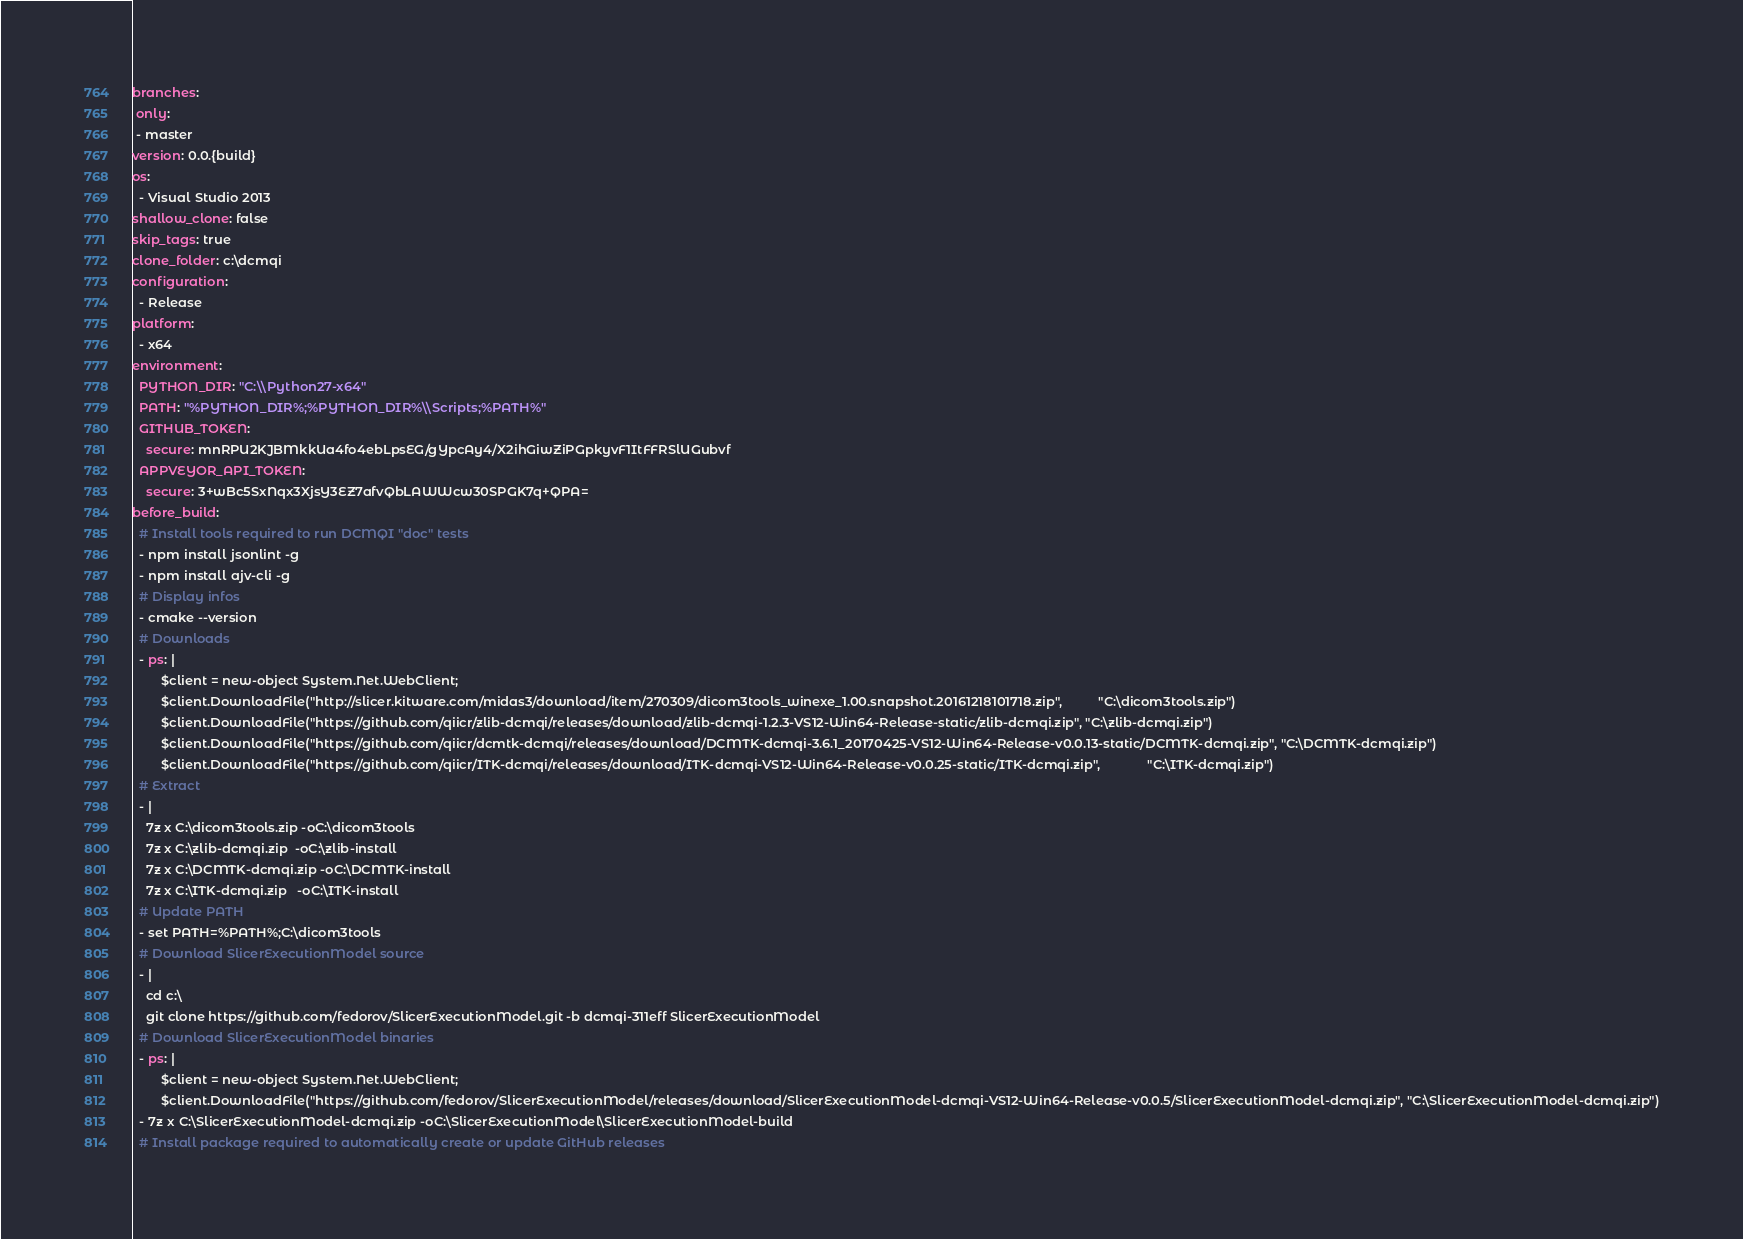<code> <loc_0><loc_0><loc_500><loc_500><_YAML_>branches:
 only:
 - master
version: 0.0.{build}
os:
  - Visual Studio 2013
shallow_clone: false
skip_tags: true
clone_folder: c:\dcmqi
configuration:
  - Release
platform:
  - x64
environment:
  PYTHON_DIR: "C:\\Python27-x64"
  PATH: "%PYTHON_DIR%;%PYTHON_DIR%\\Scripts;%PATH%"
  GITHUB_TOKEN:
    secure: mnRPU2KJBMkkUa4fo4ebLpsEG/gYpcAy4/X2ihGiwZiPGpkyvF1ItFFRSlUGubvf
  APPVEYOR_API_TOKEN:
    secure: 3+wBc5SxNqx3XjsY3EZ7afvQbLAWWcw30SPGK7q+QPA=
before_build:
  # Install tools required to run DCMQI "doc" tests
  - npm install jsonlint -g
  - npm install ajv-cli -g
  # Display infos
  - cmake --version
  # Downloads
  - ps: |
        $client = new-object System.Net.WebClient;
        $client.DownloadFile("http://slicer.kitware.com/midas3/download/item/270309/dicom3tools_winexe_1.00.snapshot.20161218101718.zip",          "C:\dicom3tools.zip")
        $client.DownloadFile("https://github.com/qiicr/zlib-dcmqi/releases/download/zlib-dcmqi-1.2.3-VS12-Win64-Release-static/zlib-dcmqi.zip", "C:\zlib-dcmqi.zip")
        $client.DownloadFile("https://github.com/qiicr/dcmtk-dcmqi/releases/download/DCMTK-dcmqi-3.6.1_20170425-VS12-Win64-Release-v0.0.13-static/DCMTK-dcmqi.zip", "C:\DCMTK-dcmqi.zip")
        $client.DownloadFile("https://github.com/qiicr/ITK-dcmqi/releases/download/ITK-dcmqi-VS12-Win64-Release-v0.0.25-static/ITK-dcmqi.zip",             "C:\ITK-dcmqi.zip")
  # Extract
  - |
    7z x C:\dicom3tools.zip -oC:\dicom3tools
    7z x C:\zlib-dcmqi.zip  -oC:\zlib-install
    7z x C:\DCMTK-dcmqi.zip -oC:\DCMTK-install
    7z x C:\ITK-dcmqi.zip   -oC:\ITK-install
  # Update PATH
  - set PATH=%PATH%;C:\dicom3tools
  # Download SlicerExecutionModel source
  - |
    cd c:\
    git clone https://github.com/fedorov/SlicerExecutionModel.git -b dcmqi-311eff SlicerExecutionModel
  # Download SlicerExecutionModel binaries
  - ps: |
        $client = new-object System.Net.WebClient;
        $client.DownloadFile("https://github.com/fedorov/SlicerExecutionModel/releases/download/SlicerExecutionModel-dcmqi-VS12-Win64-Release-v0.0.5/SlicerExecutionModel-dcmqi.zip", "C:\SlicerExecutionModel-dcmqi.zip")
  - 7z x C:\SlicerExecutionModel-dcmqi.zip -oC:\SlicerExecutionModel\SlicerExecutionModel-build
  # Install package required to automatically create or update GitHub releases</code> 